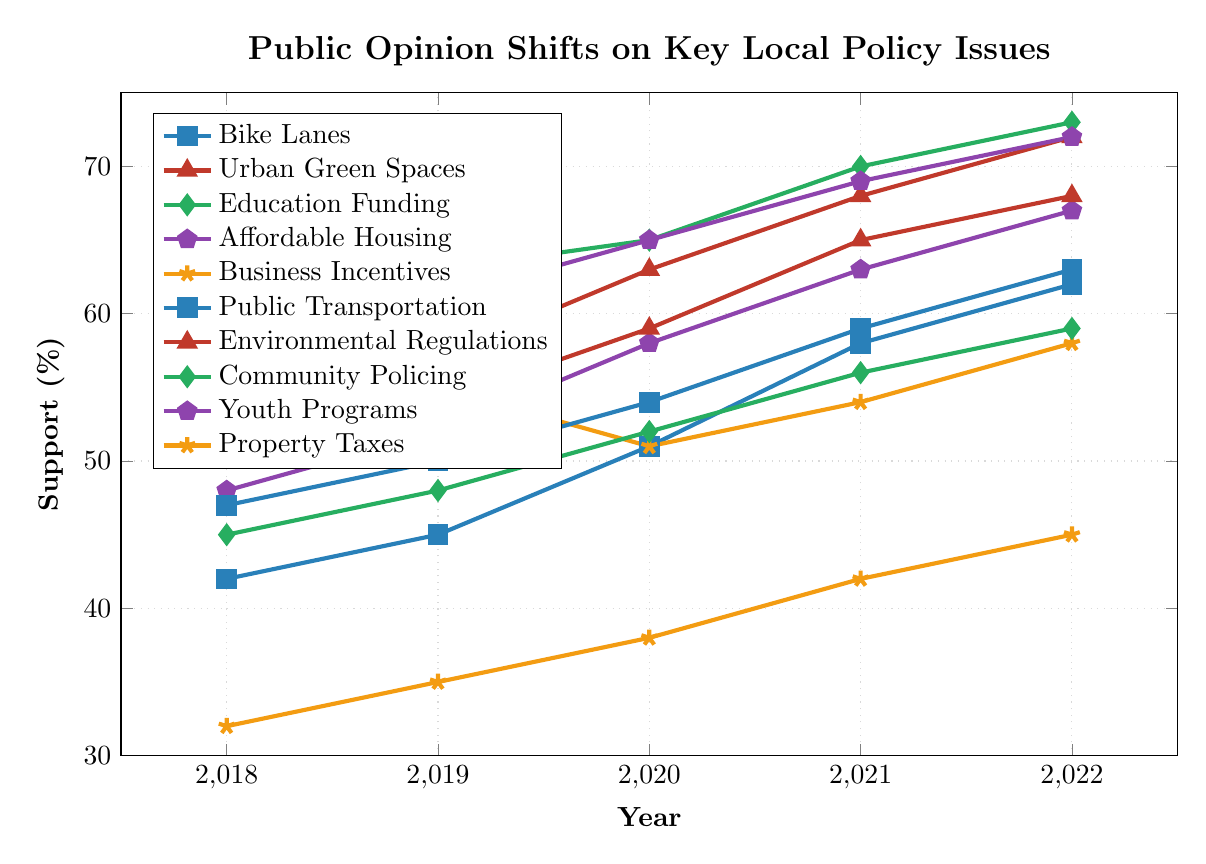What policy issue saw the greatest increase in support from 2018 to 2022? Identify the starting and ending points for all the issues and subtract the 2018 values from the 2022 values to find the increases. Support for Bike Lanes increased by 20 (62-42), Urban Green Spaces by 17 (72-55), Increased Education Funding by 12 (73-61), Affordable Housing by 19 (67-48), Local Business Incentives by 5 (58-53), Public Transportation Expansion by 16 (63-47), Stricter Environmental Regulations by 17 (68-51), Community Policing Initiatives by 14 (59-45), Youth Development Programs by 14 (72-58), and Increased Property Taxes for Infrastructure by 13 (45-32). Support for Bike Lanes had the greatest increase of 20 points.
Answer: Bike Lanes Between 2020 and 2021, which policy saw the largest increase in support? Look at the values for 2020 and 2021 for each policy and calculate the differences. Support for Bike Lanes increased by 7 (58-51), Urban Green Spaces by 5 (68-63), Increased Education Funding by 5 (70-65), Affordable Housing by 5 (63-58), Local Business Incentives by 3 (54-51), Public Transportation Expansion by 5 (59-54), Stricter Environmental Regulations by 6 (65-59), Community Policing Initiatives by 4 (56-52), Youth Development Programs by 4 (69-65), and Increased Property Taxes for Infrastructure by 4 (42-38). Support for Bike Lanes had the largest increase of 7 points.
Answer: Bike Lanes Which policy had the lowest support in 2018 and what was its value? Identify the values for each policy in 2018 and choose the smallest one. Increased Property Taxes for Infrastructure had the lowest support at 32%.
Answer: Increased Property Taxes for Infrastructure, 32% What was the average support for Affordable Housing over the 5 years? Add the yearly support percentages for Affordable Housing and divide by the number of years: (48 + 52 + 58 + 63 + 67) / 5 = 288 / 5 = 57.6.
Answer: 57.6% In 2022, did more people support Youth Development Programs or Urban Green Spaces? Compare the support percentages for Youth Development Programs and Urban Green Spaces in 2022: Youth Development Programs 72% and Urban Green Spaces 72%. Since they are equal, the support levels are the same.
Answer: Equal What is the difference in support between Urban Green Spaces and Local Business Incentives in 2022? Subtract the 2022 support value for Local Business Incentives from Urban Green Spaces: 72 - 58 = 14.
Answer: 14 Which policy had the most consistent increase in support each year? Identify the policies with the same increase each year. For Support for Bike Lanes: (45-42=3, 51-45=6, 58-51=7, 62-58=4), Support for Youth Development Programs: (61-58=3, 65-61=4, 69-65=4, 72-69=3), Education Funding: (63-61=2, 65-63=2, 70-65=5, 73-70=3) and look for those with similar values. Support for Youth Development Programs had the most consistent increase.
Answer: Youth Development Programs By how much did the support for Stricter Environmental Regulations increase from 2020 to 2022? Subtract the support value in 2020 from the support value in 2022: 68 - 59 = 9.
Answer: 9 What was the median support value for all policies in 2021? List all the 2021 values and find the middle one after ordering them: (42, 54, 56, 58, 59, 63, 65, 68, 69, 70). The median is the average of the fifth and sixth values: (59 + 63) / 2 = 61.
Answer: 61 What is the trend for Public Transportation Expansion from 2018 to 2022? Observe the yearly values: (47, 50, 54, 59, 63). The values are increasing each year, indicating a positive trend.
Answer: Positive trend 